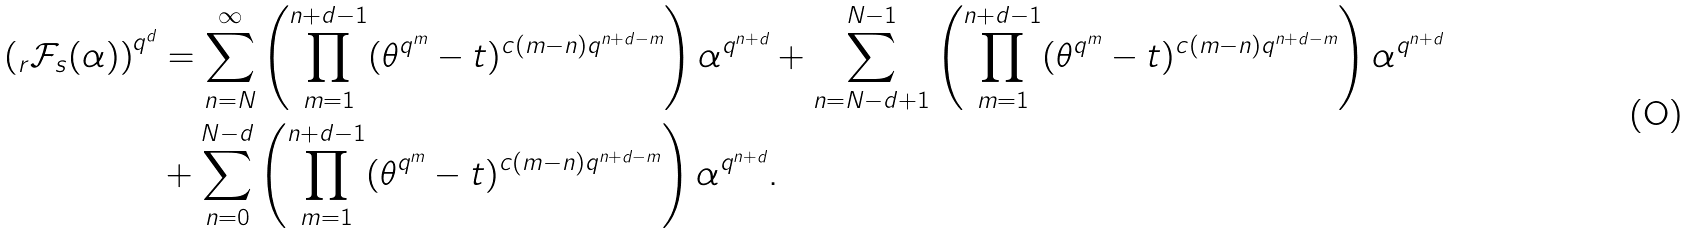<formula> <loc_0><loc_0><loc_500><loc_500>\left ( _ { r } \mathcal { F } _ { s } ( \alpha ) \right ) ^ { q ^ { d } } & = \sum _ { n = N } ^ { \infty } \left ( \prod _ { m = 1 } ^ { n + d - 1 } ( \theta ^ { q ^ { m } } - t ) ^ { c ( m - n ) q ^ { n + d - m } } \right ) \alpha ^ { q ^ { n + d } } + \sum _ { n = N - d + 1 } ^ { N - 1 } \left ( \prod _ { m = 1 } ^ { n + d - 1 } ( \theta ^ { q ^ { m } } - t ) ^ { c ( m - n ) q ^ { n + d - m } } \right ) \alpha ^ { q ^ { n + d } } \\ & + \sum _ { n = 0 } ^ { N - d } \left ( \prod _ { m = 1 } ^ { n + d - 1 } ( \theta ^ { q ^ { m } } - t ) ^ { c ( m - n ) q ^ { n + d - m } } \right ) \alpha ^ { q ^ { n + d } } .</formula> 